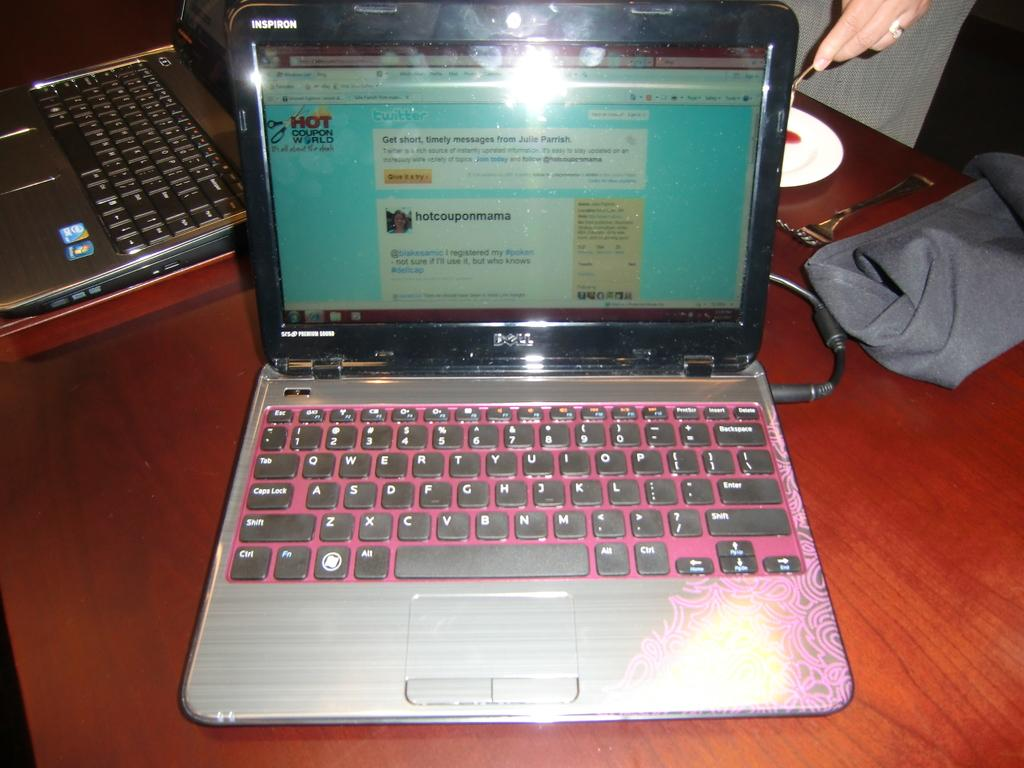What is located at the bottom of the image? There is a table at the bottom of the image. What electronic devices are on the table? There are laptops on the table. What utensil is on the table? There is a fork on the table. What type of fabric is on the table? There is a cloth on the table. What is used for holding liquids on the table? There is a saucer on the table. Whose hand is holding a spoon in the image? There is a hand holding a spoon in the image, but it is not specified whose hand it is. What type of nail is being hammered into the bridge in the image? There is no nail or bridge present in the image; it features a table with various objects on it. 